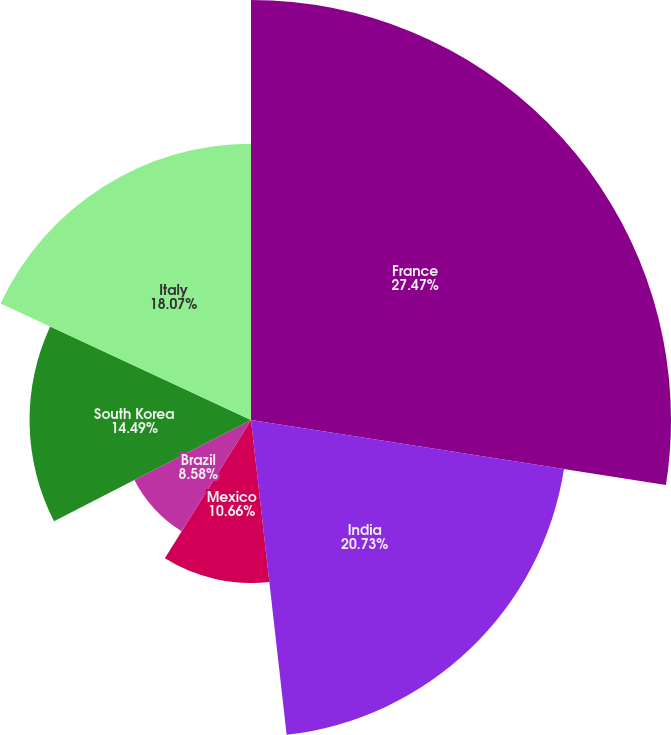Convert chart to OTSL. <chart><loc_0><loc_0><loc_500><loc_500><pie_chart><fcel>France<fcel>India<fcel>Mexico<fcel>Brazil<fcel>South Korea<fcel>Italy<nl><fcel>27.48%<fcel>20.73%<fcel>10.66%<fcel>8.58%<fcel>14.49%<fcel>18.07%<nl></chart> 